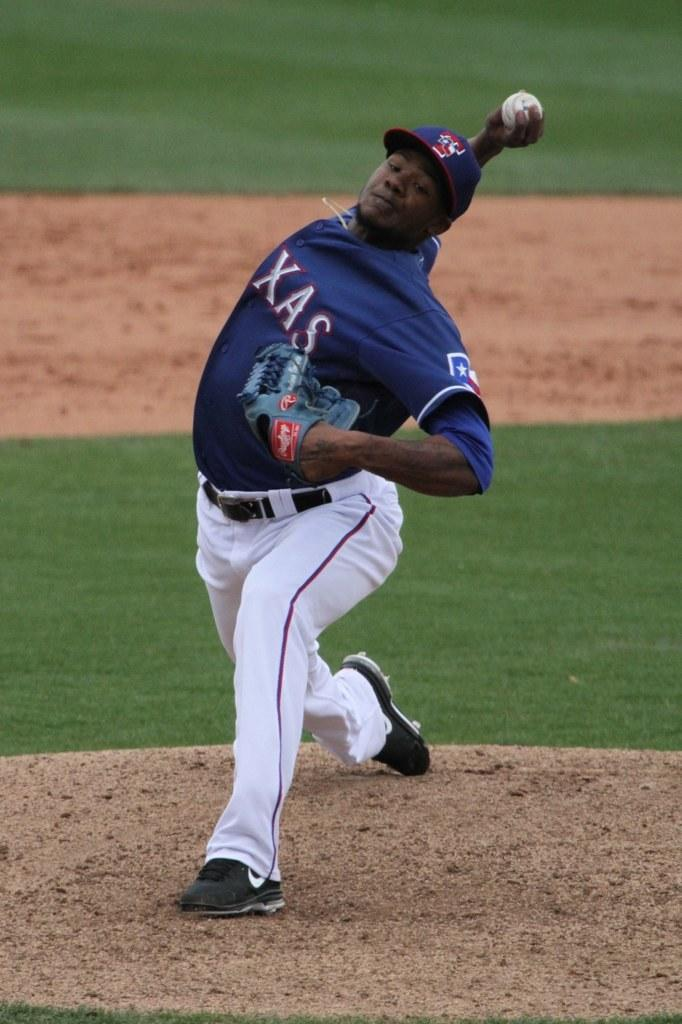<image>
Write a terse but informative summary of the picture. Baseball player wearing a Texas jersey pitching a ball. 